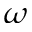Convert formula to latex. <formula><loc_0><loc_0><loc_500><loc_500>\omega</formula> 